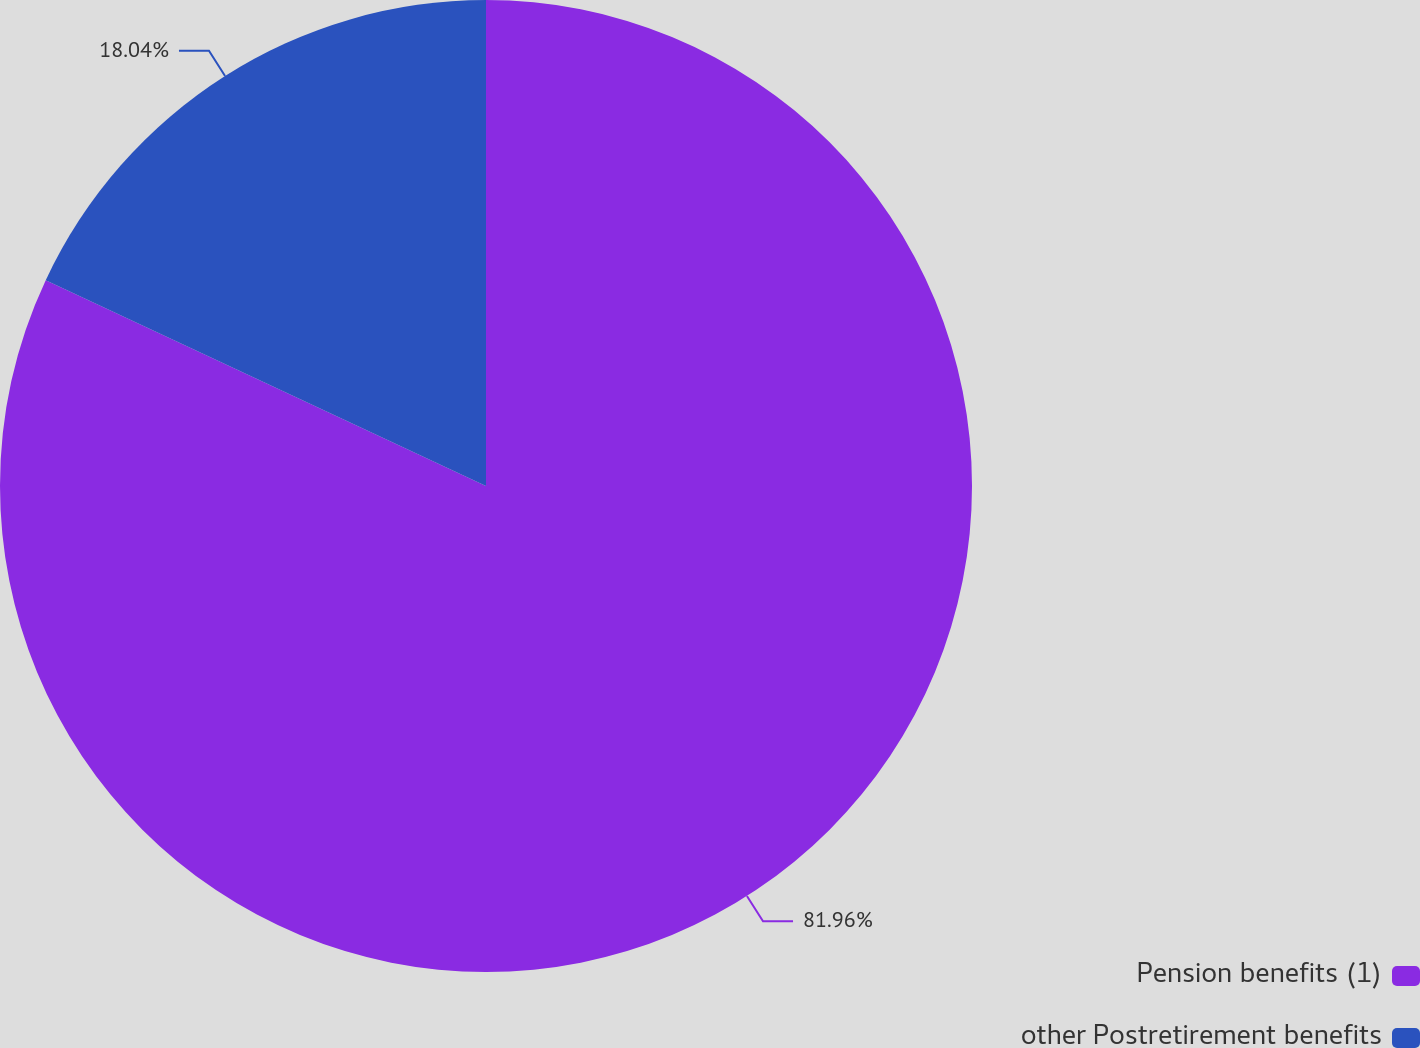Convert chart to OTSL. <chart><loc_0><loc_0><loc_500><loc_500><pie_chart><fcel>Pension benefits (1)<fcel>other Postretirement benefits<nl><fcel>81.96%<fcel>18.04%<nl></chart> 